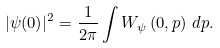Convert formula to latex. <formula><loc_0><loc_0><loc_500><loc_500>| \psi ( 0 ) | ^ { 2 } = \frac { 1 } { 2 \pi } \int W _ { \psi } \left ( 0 , p \right ) \, d p .</formula> 